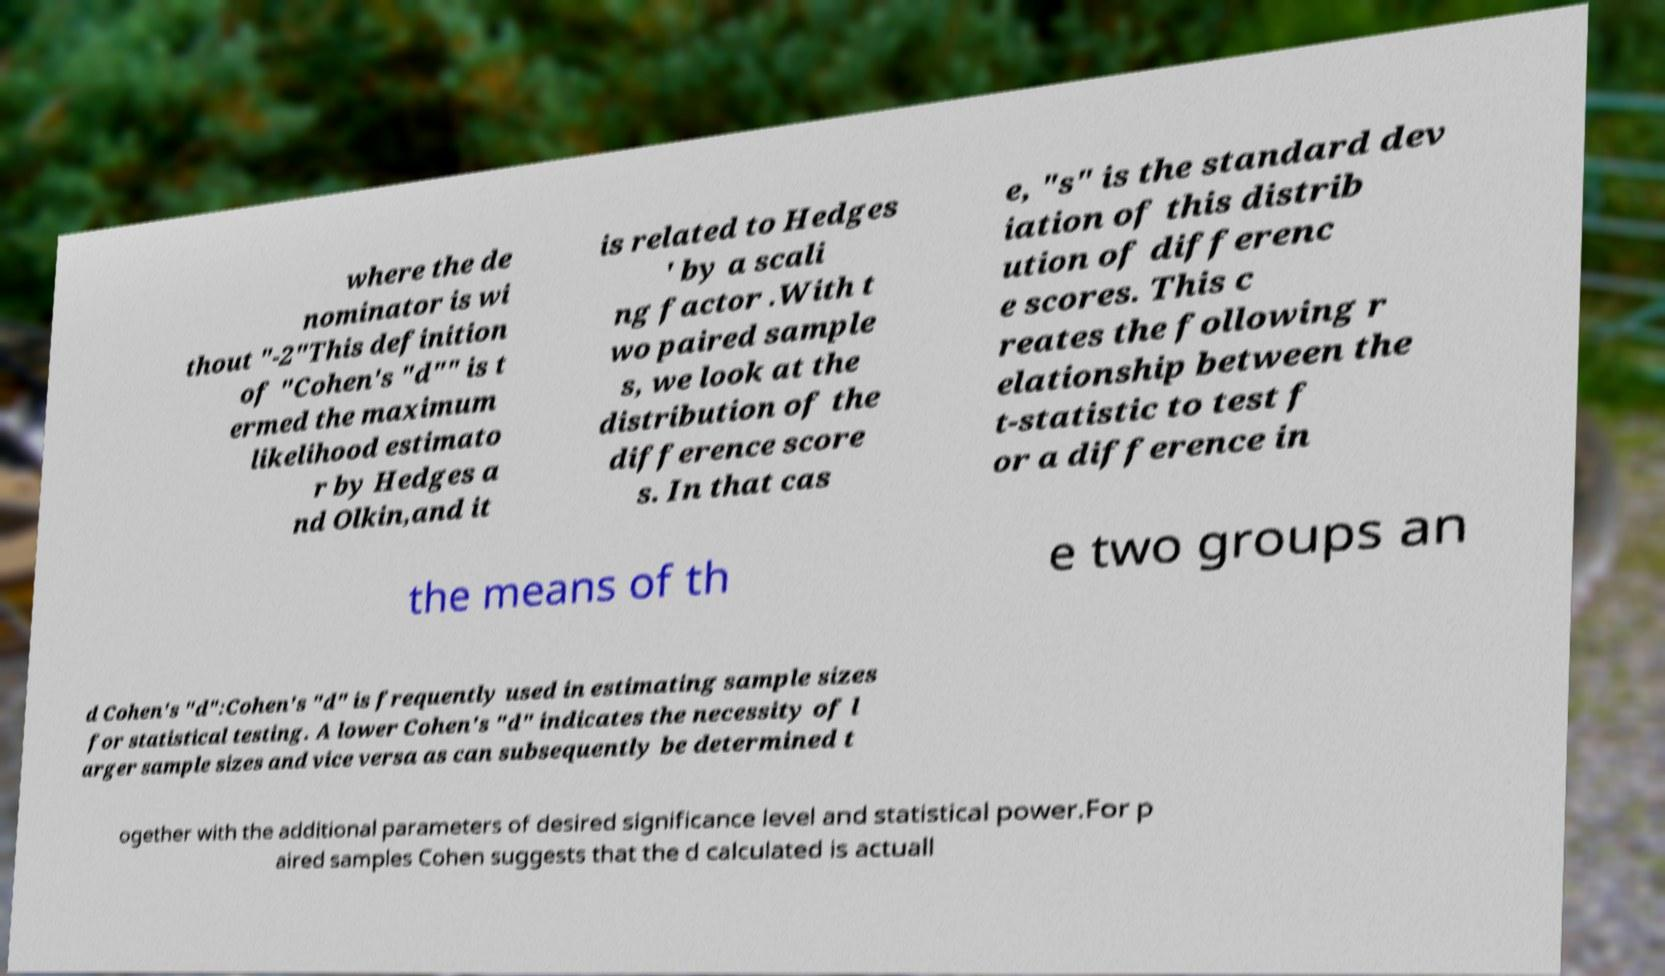There's text embedded in this image that I need extracted. Can you transcribe it verbatim? where the de nominator is wi thout "-2"This definition of "Cohen's "d"" is t ermed the maximum likelihood estimato r by Hedges a nd Olkin,and it is related to Hedges ' by a scali ng factor .With t wo paired sample s, we look at the distribution of the difference score s. In that cas e, "s" is the standard dev iation of this distrib ution of differenc e scores. This c reates the following r elationship between the t-statistic to test f or a difference in the means of th e two groups an d Cohen's "d":Cohen's "d" is frequently used in estimating sample sizes for statistical testing. A lower Cohen's "d" indicates the necessity of l arger sample sizes and vice versa as can subsequently be determined t ogether with the additional parameters of desired significance level and statistical power.For p aired samples Cohen suggests that the d calculated is actuall 